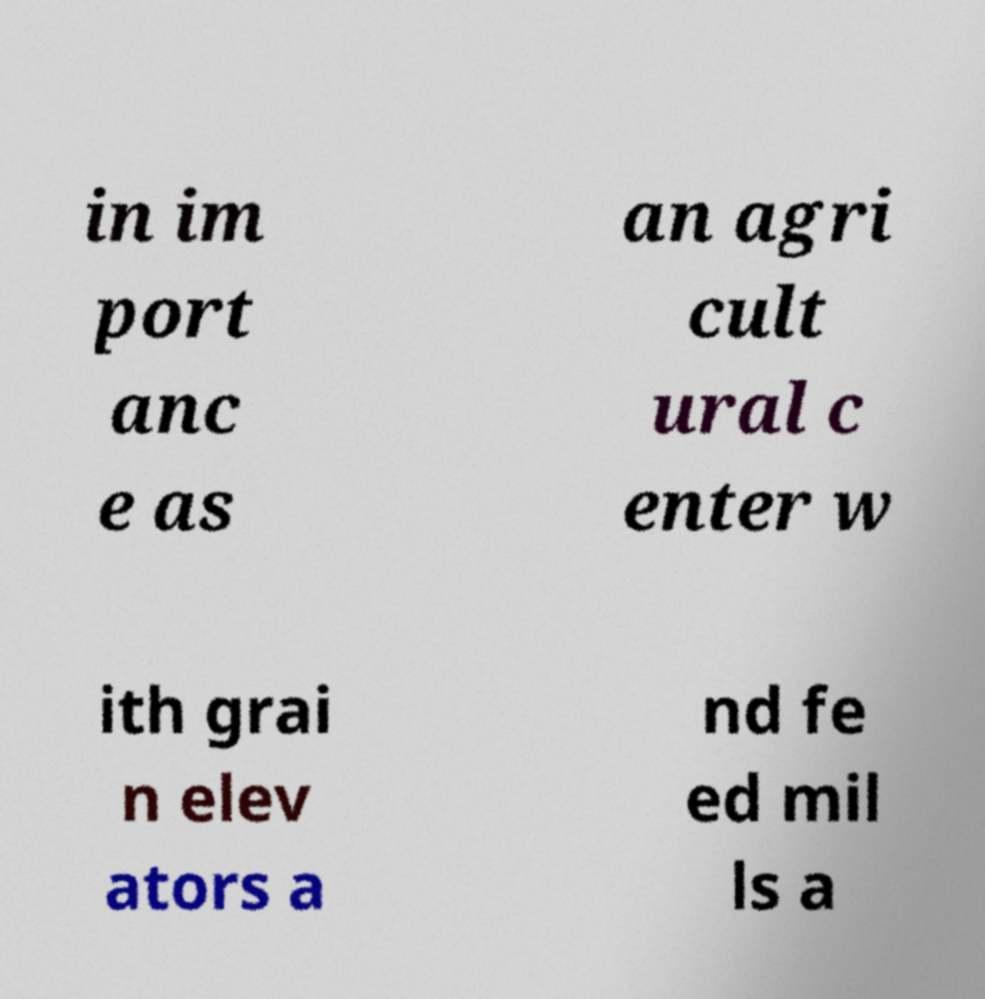I need the written content from this picture converted into text. Can you do that? in im port anc e as an agri cult ural c enter w ith grai n elev ators a nd fe ed mil ls a 